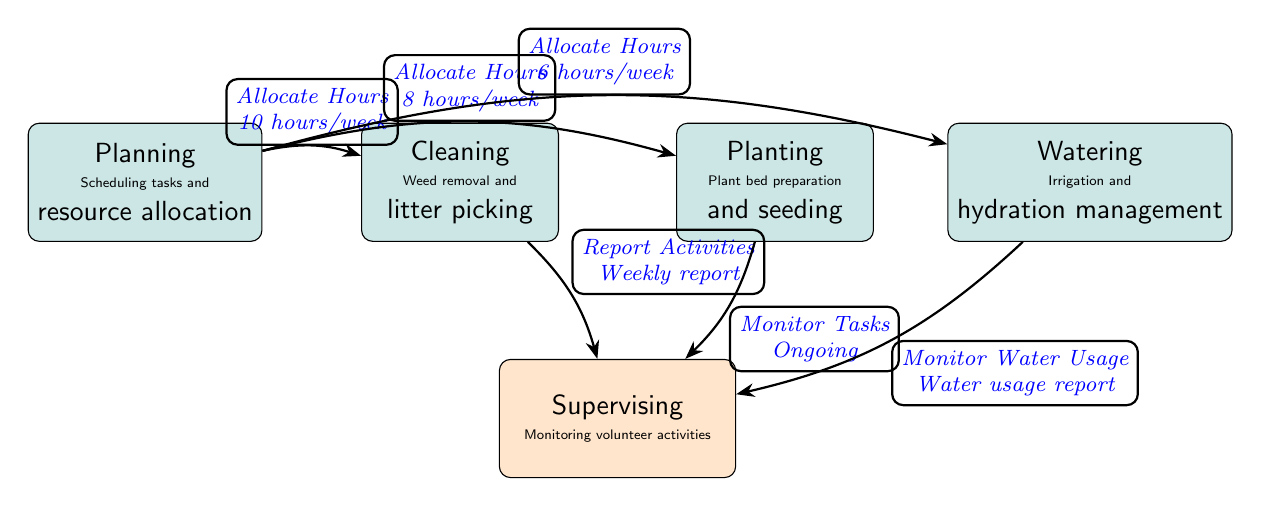What is the role that requires the most hours allocated? The role of cleaning is allocated 10 hours per week, which is the highest allocation in the diagram.
Answer: Cleaning How many roles are involved in garden maintenance? There are four distinct roles identified in the diagram: planning, cleaning, planting, and watering.
Answer: Four What is the key responsibility associated with the planting role? The planting role includes the responsibility of plant bed preparation and seeding, as described within the node.
Answer: Plant bed preparation and seeding Which role has a monitoring function associated with it? The supervising role has a monitoring function, as indicated by the arrows directing from the other roles to supervising.
Answer: Supervising How many total hours are allocated among all roles? The total hours allocated is 10 (cleaning) + 8 (planting) + 6 (watering) = 24 hours per week when summed.
Answer: 24 hours Which role reports activities weekly to supervising? The cleaning role is the one that reports activities weekly to the supervising role, as shown by the directed arrow.
Answer: Cleaning What does the watering role specifically manage? The watering role specifically manages irrigation and hydration, as noted in the description of that role node.
Answer: Irrigation and hydration How many edges are in the diagram? The diagram contains three edges leading from planning to other roles and three edges leading from those roles to supervising, totaling six edges.
Answer: Six What type of diagram is this? This diagram is a textbook diagram, which is designed to clearly represent roles and relationships in a structured format.
Answer: Textbook diagram 